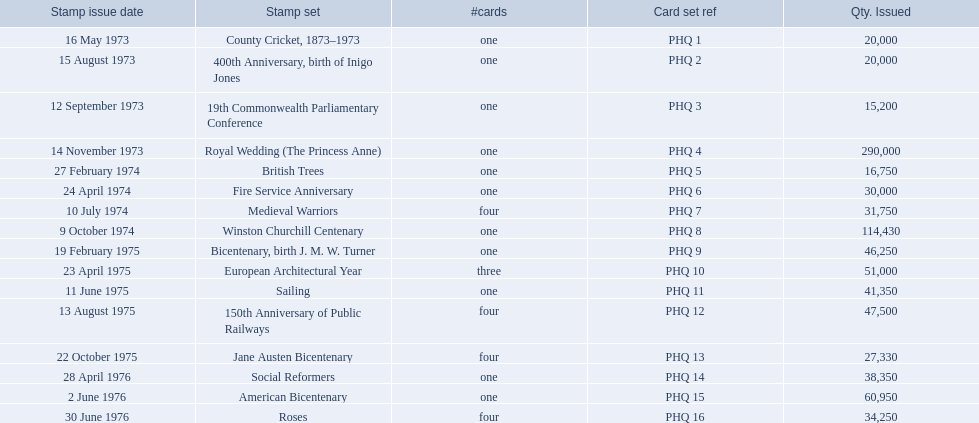Which stamp series were introduced? County Cricket, 1873–1973, 400th Anniversary, birth of Inigo Jones, 19th Commonwealth Parliamentary Conference, Royal Wedding (The Princess Anne), British Trees, Fire Service Anniversary, Medieval Warriors, Winston Churchill Centenary, Bicentenary, birth J. M. W. Turner, European Architectural Year, Sailing, 150th Anniversary of Public Railways, Jane Austen Bicentenary, Social Reformers, American Bicentenary, Roses. From those series, which had in excess of 200,000 issued? Royal Wedding (The Princess Anne). Which stamp collections were released? County Cricket, 1873–1973, 400th Anniversary, birth of Inigo Jones, 19th Commonwealth Parliamentary Conference, Royal Wedding (The Princess Anne), British Trees, Fire Service Anniversary, Medieval Warriors, Winston Churchill Centenary, Bicentenary, birth J. M. W. Turner, European Architectural Year, Sailing, 150th Anniversary of Public Railways, Jane Austen Bicentenary, Social Reformers, American Bicentenary, Roses. Among those collections, which had over 200,000 issued? Royal Wedding (The Princess Anne). 